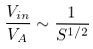Convert formula to latex. <formula><loc_0><loc_0><loc_500><loc_500>\frac { V _ { i n } } { V _ { A } } \sim \frac { 1 } { S ^ { 1 / 2 } }</formula> 